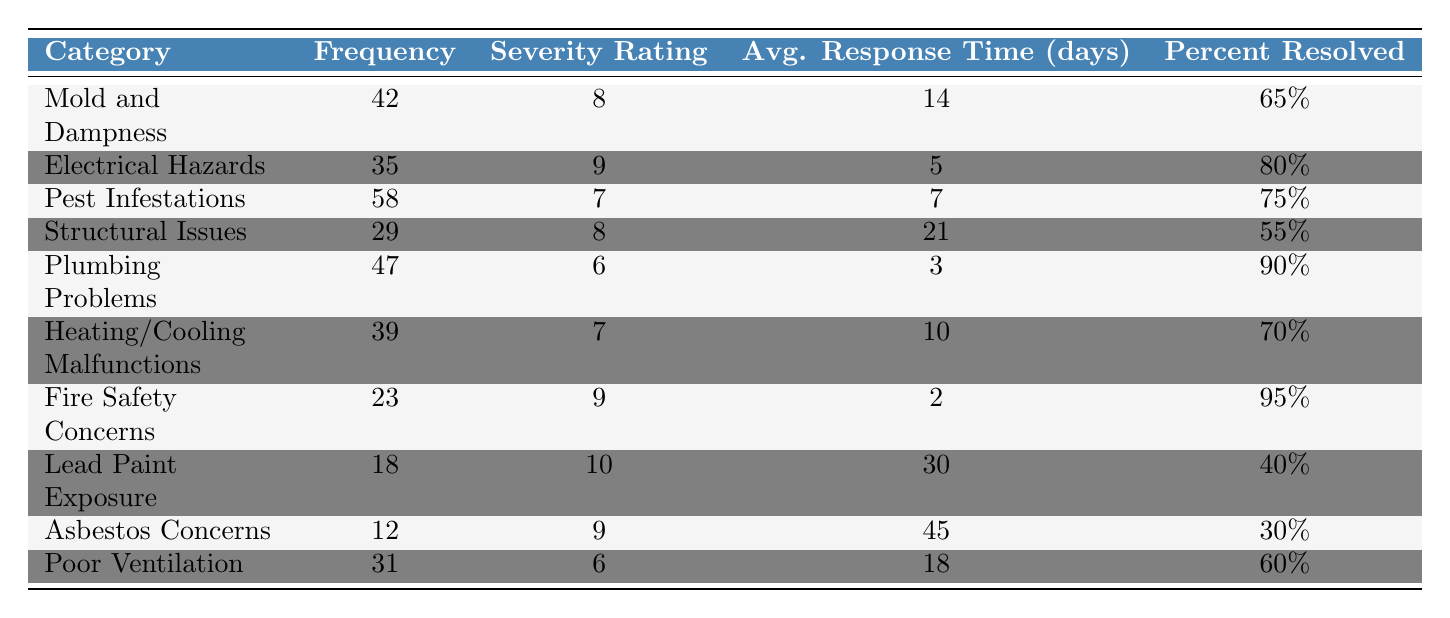What is the category with the highest frequency of complaints? The frequency column shows that "Pest Infestations" has the highest frequency of 58 complaints.
Answer: Pest Infestations What is the severity rating for "Lead Paint Exposure"? The severity rating for "Lead Paint Exposure" is found in the severity rating column, which shows a value of 10.
Answer: 10 How many categories have a frequency greater than 40? Looking at the frequency column, the categories with a frequency greater than 40 are "Mold and Dampness", "Pest Infestations", "Plumbing Problems", and "Heating/Cooling Malfunctions". This totals to 4 categories.
Answer: 4 What is the average response time for structural issues? The average response time for "Structural Issues" is listed in the table, showing a value of 21 days.
Answer: 21 days Are there any complaints with a severity rating of 10? Yes, "Lead Paint Exposure" is the only category with a severity rating of 10.
Answer: Yes Which category has the lowest percent resolved? By examining the percent resolved column, "Asbestos Concerns" has the lowest percentage at 30%.
Answer: Asbestos Concerns What is the difference in average response time between "Fire Safety Concerns" and "Lead Paint Exposure"? The average response time for "Fire Safety Concerns" is 2 days, and for "Lead Paint Exposure" it is 30 days. The difference is calculated as 30 - 2 = 28 days.
Answer: 28 days What is the total number of complaints for all categories? To find the total, we add the frequency of all categories: 42 + 35 + 58 + 29 + 47 + 39 + 23 + 18 + 12 + 31 = 392.
Answer: 392 Which category has the highest severity rating and what is that rating? The maximum severity rating is 10 for "Lead Paint Exposure", making it the highest.
Answer: Lead Paint Exposure, 10 Is the average response time for "Plumbing Problems" less than the average response time for "Heating/Cooling Malfunctions"? The average response time for "Plumbing Problems" is 3 days and for "Heating/Cooling Malfunctions" it is 10 days. Since 3 is less than 10, the statement is true.
Answer: Yes 